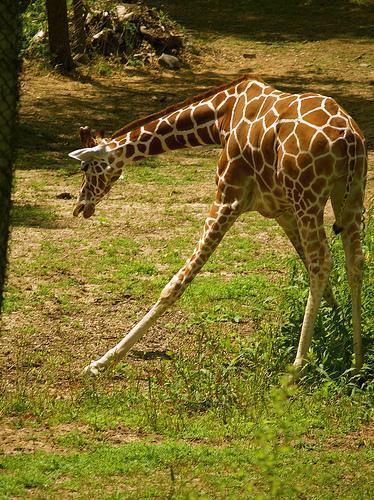How many giraffes?
Give a very brief answer. 1. 